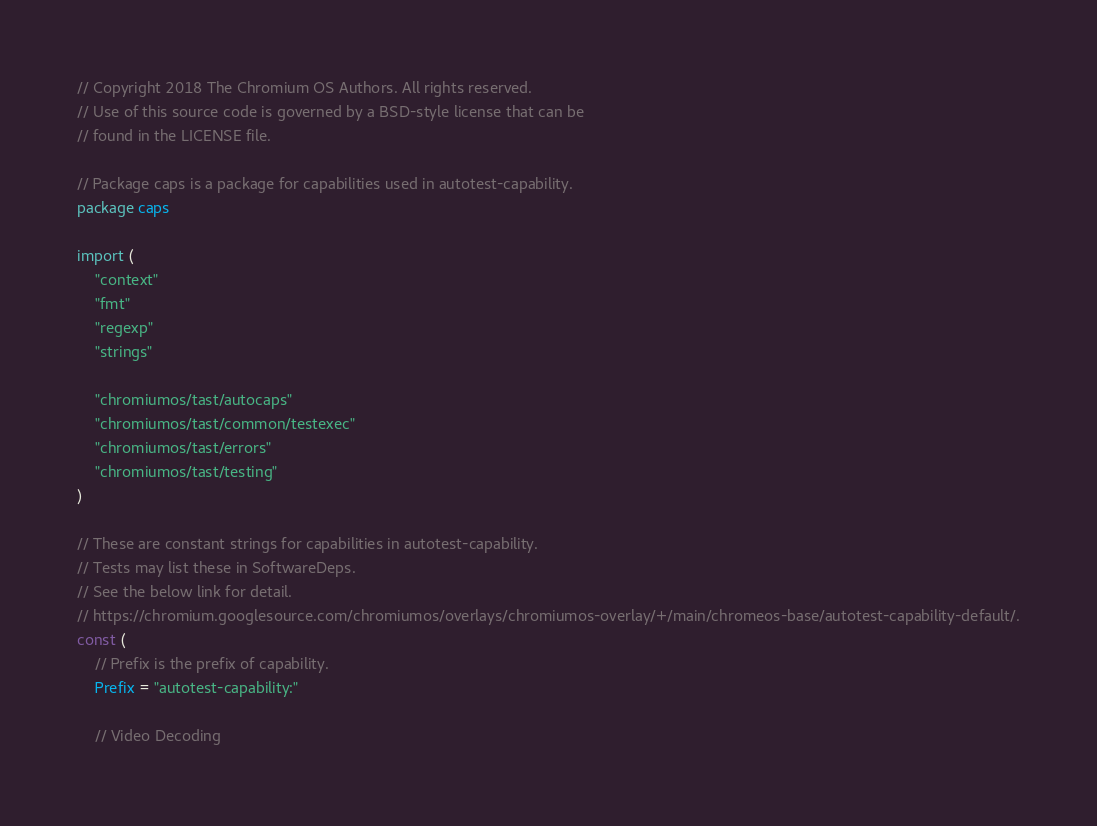<code> <loc_0><loc_0><loc_500><loc_500><_Go_>// Copyright 2018 The Chromium OS Authors. All rights reserved.
// Use of this source code is governed by a BSD-style license that can be
// found in the LICENSE file.

// Package caps is a package for capabilities used in autotest-capability.
package caps

import (
	"context"
	"fmt"
	"regexp"
	"strings"

	"chromiumos/tast/autocaps"
	"chromiumos/tast/common/testexec"
	"chromiumos/tast/errors"
	"chromiumos/tast/testing"
)

// These are constant strings for capabilities in autotest-capability.
// Tests may list these in SoftwareDeps.
// See the below link for detail.
// https://chromium.googlesource.com/chromiumos/overlays/chromiumos-overlay/+/main/chromeos-base/autotest-capability-default/.
const (
	// Prefix is the prefix of capability.
	Prefix = "autotest-capability:"

	// Video Decoding</code> 